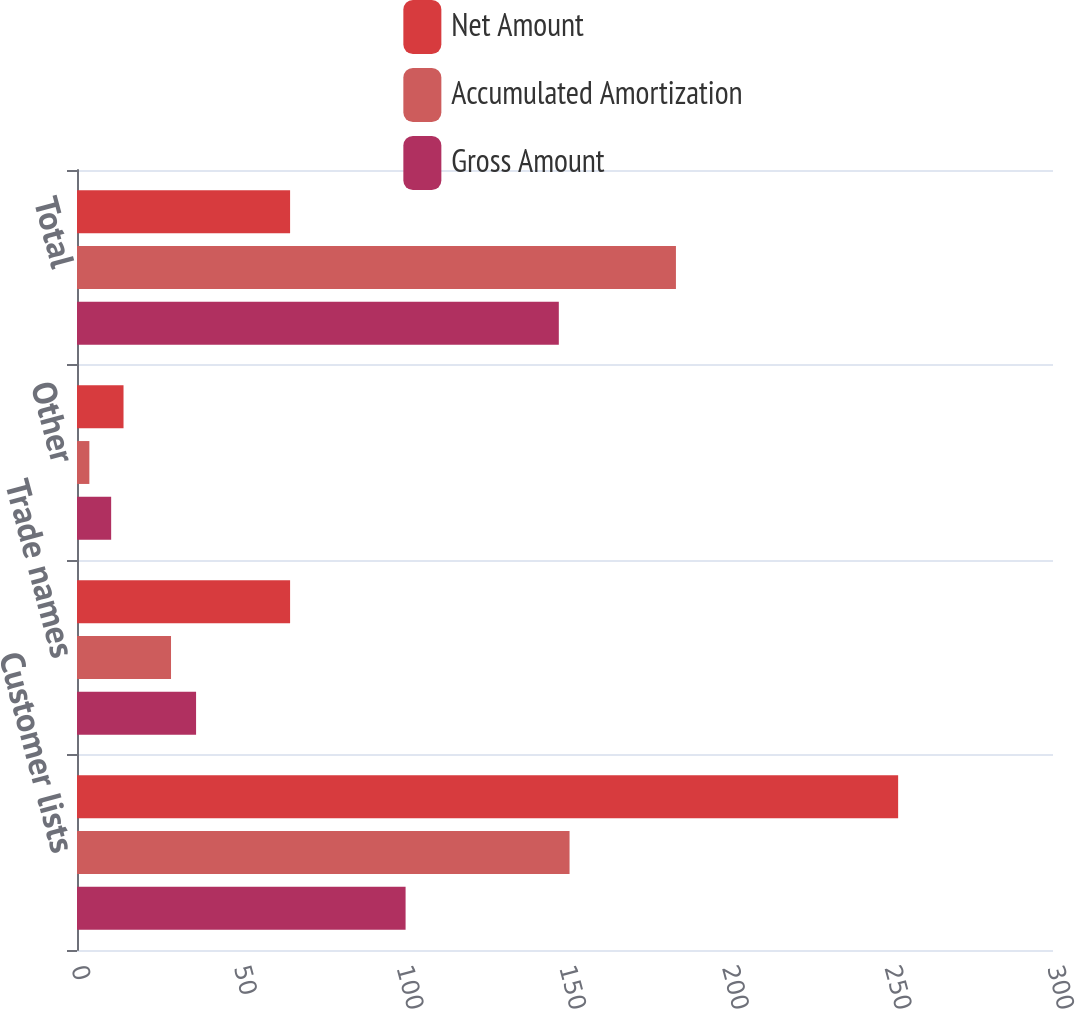<chart> <loc_0><loc_0><loc_500><loc_500><stacked_bar_chart><ecel><fcel>Customer lists<fcel>Trade names<fcel>Other<fcel>Total<nl><fcel>Net Amount<fcel>252.4<fcel>65.5<fcel>14.3<fcel>65.5<nl><fcel>Accumulated Amortization<fcel>151.4<fcel>28.9<fcel>3.8<fcel>184.1<nl><fcel>Gross Amount<fcel>101<fcel>36.6<fcel>10.5<fcel>148.1<nl></chart> 